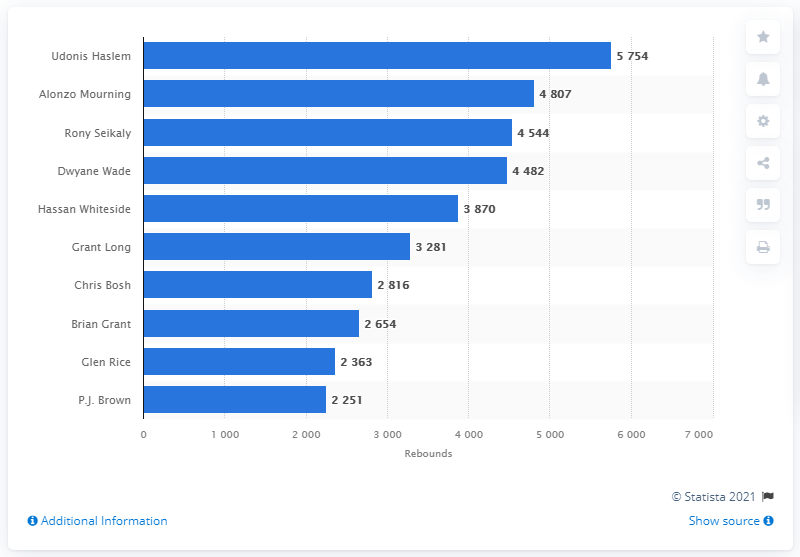Mention a couple of crucial points in this snapshot. Udonis Haslem is the career rebounds leader of the Miami Heat. 